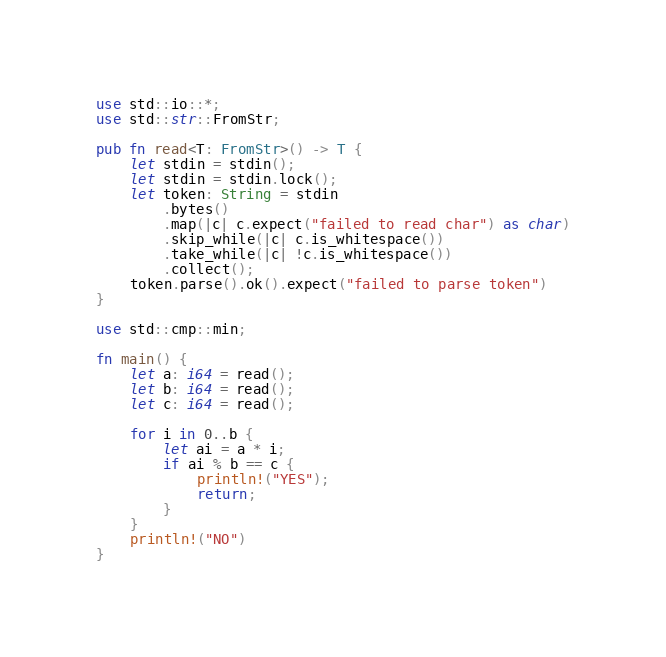Convert code to text. <code><loc_0><loc_0><loc_500><loc_500><_Rust_>use std::io::*;
use std::str::FromStr;

pub fn read<T: FromStr>() -> T {
    let stdin = stdin();
    let stdin = stdin.lock();
    let token: String = stdin
        .bytes()
        .map(|c| c.expect("failed to read char") as char)
        .skip_while(|c| c.is_whitespace())
        .take_while(|c| !c.is_whitespace())
        .collect();
    token.parse().ok().expect("failed to parse token")
}

use std::cmp::min;

fn main() {
    let a: i64 = read();
    let b: i64 = read();
    let c: i64 = read();

    for i in 0..b {
        let ai = a * i;
        if ai % b == c {
            println!("YES");
            return;
        }
    }
    println!("NO")
}
</code> 